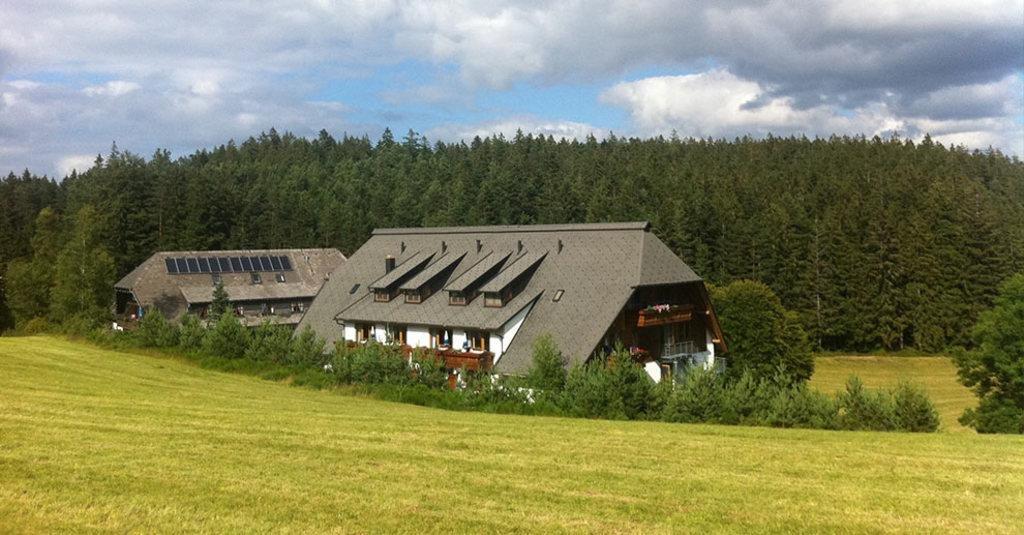What type of terrain is visible in the image? There is an open grass ground in the image. What can be found on the grass ground? There are plants on the grass ground. How many buildings are present in the image? There are two buildings in the image. What is visible in the background of the image? There are trees, clouds, and the sky visible in the background of the image. What type of hands can be seen holding the church in the image? There is no church or hands present in the image. 